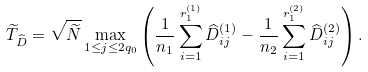Convert formula to latex. <formula><loc_0><loc_0><loc_500><loc_500>\widetilde { T } _ { \widehat { D } } = \sqrt { \widetilde { N } } \max _ { 1 \leq j \leq 2 q _ { 0 } } \left ( \frac { 1 } { n _ { 1 } } \sum ^ { r _ { 1 } ^ { ( 1 ) } } _ { i = 1 } \widehat { D } _ { i j } ^ { ( 1 ) } - \frac { 1 } { n _ { 2 } } \sum ^ { r _ { 1 } ^ { ( 2 ) } } _ { i = 1 } \widehat { D } _ { i j } ^ { ( 2 ) } \right ) .</formula> 